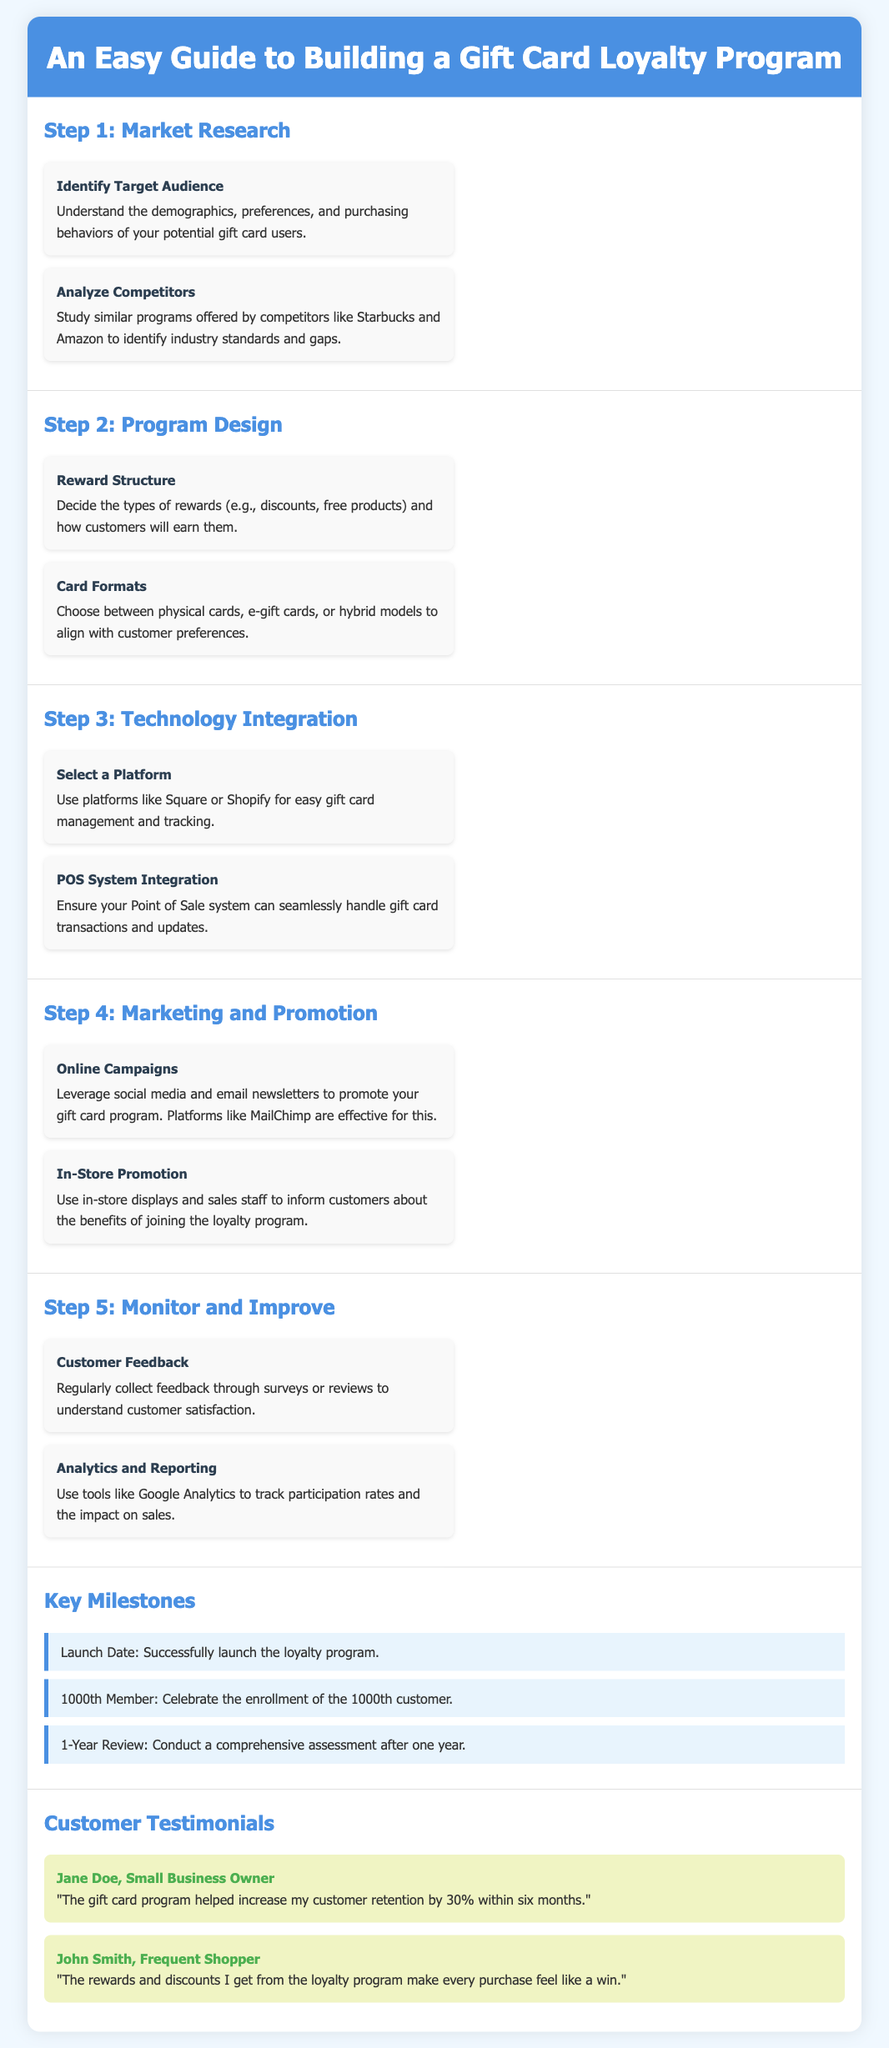what is the title of the document? The title is found at the top of the document, summarizing its purpose and content.
Answer: An Easy Guide to Building a Gift Card Loyalty Program what is the first step in building a gift card loyalty program? The first step is outlined in a section that discusses initial actions, specifically addressing market understanding.
Answer: Market Research how many testimonials are included in the document? The number of testimonials is counted in the section dedicated to customer feedback regarding the program.
Answer: 2 what reward structure options are mentioned for the loyalty program? The document outlines options for rewards within the program design section, detailing what customers can earn.
Answer: discounts, free products what system should be integrated with a gift card program? This question refers to technology choices mentioned in the integration step of the process, particularly essential systems for operations.
Answer: POS system what is one key milestone celebrated after launching the program? The milestones are specific achievements noted in a separate section of the document related to the program's progress.
Answer: 1000th Member which technology platforms are suggested for gift card management? The document recommends platforms for easy management, found in the technology integration section.
Answer: Square, Shopify who is quoted in the first testimonial? The customer's name is noted in the testimonials section, highlighting insights from users of the program.
Answer: Jane Doe 